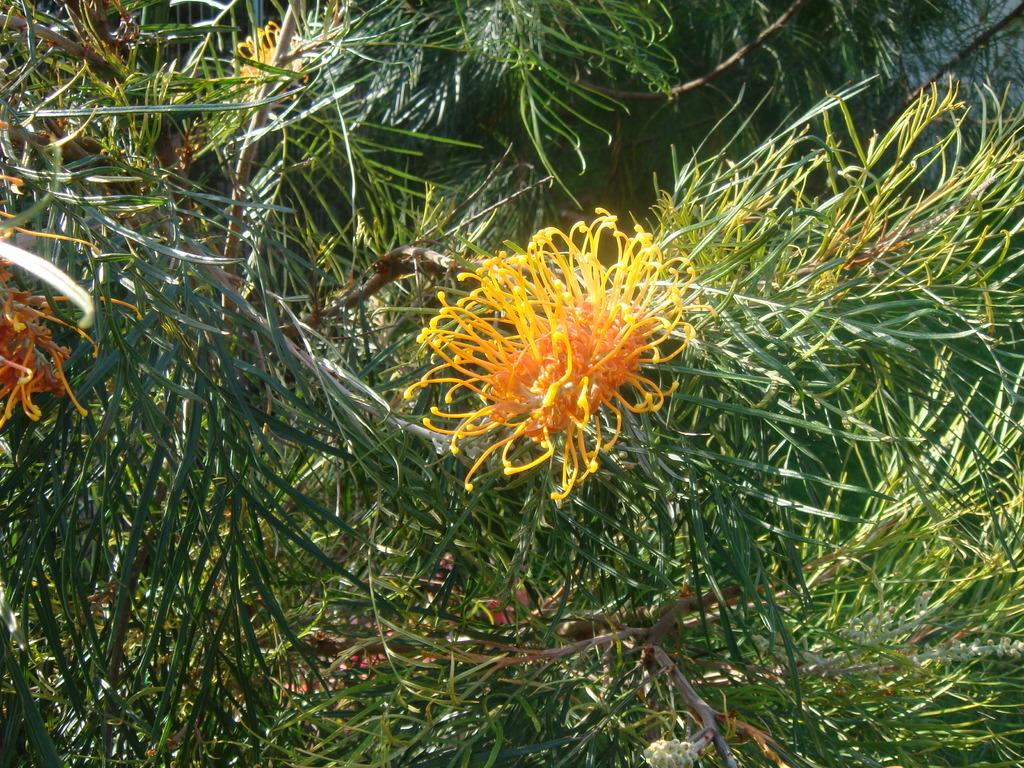What color are the flowers on the plants in the image? The flowers on the plants in the image are yellow. What flavor of ice cream is being served under the flag in the image? There is no ice cream or flag present in the image; it only features yellow flowers on plants. 